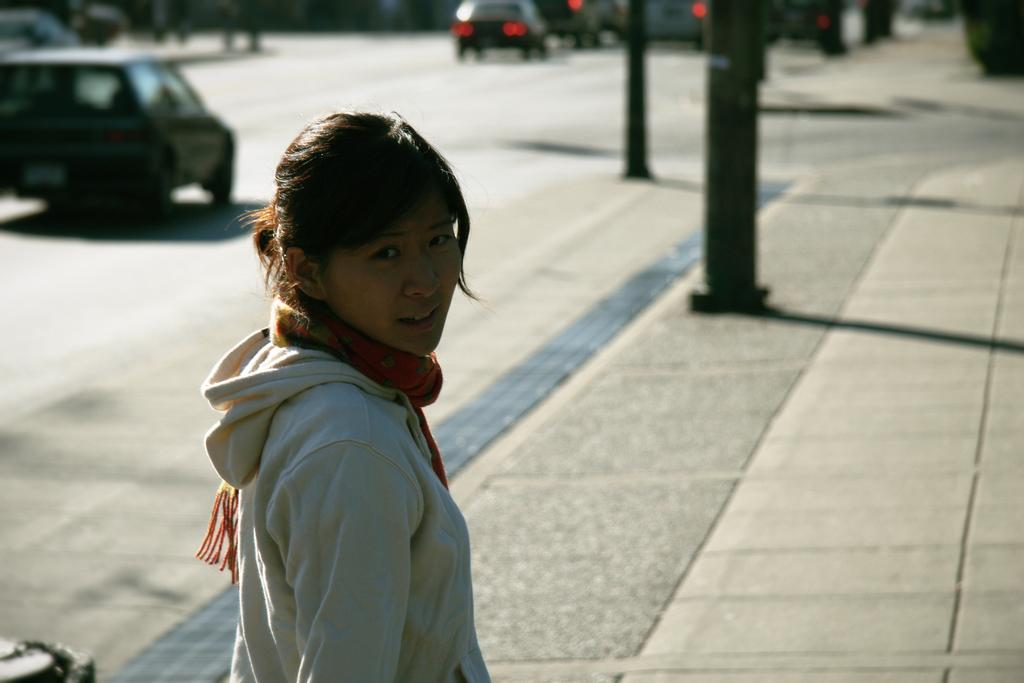Who is the main subject in the image? There is a lady highlighted in the image. What can be seen under the lady's feet? The ground is visible in the image. What type of transportation can be seen in the image? There are vehicles in the image. What is the surface on which the vehicles are moving? There is a road in the image. What are the vertical structures present in the image? Poles are present in the image. How would you describe the background of the image? The background of the image is blurred. What type of action is the rat performing on the plate in the image? There is no rat or plate present in the image. 